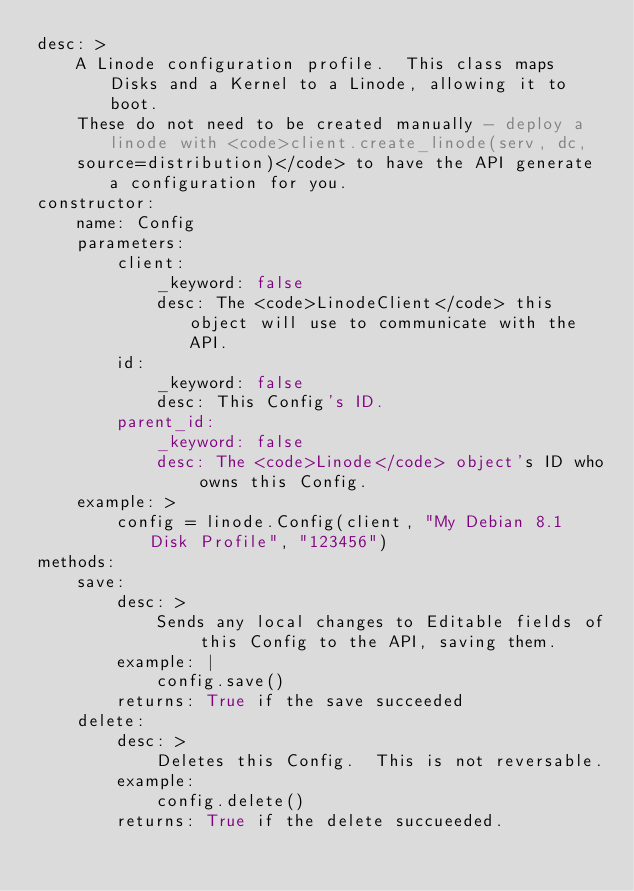<code> <loc_0><loc_0><loc_500><loc_500><_YAML_>desc: >
    A Linode configuration profile.  This class maps Disks and a Kernel to a Linode, allowing it to boot.
    These do not need to be created manually - deploy a linode with <code>client.create_linode(serv, dc, 
    source=distribution)</code> to have the API generate a configuration for you.
constructor:
    name: Config
    parameters:
        client:
            _keyword: false
            desc: The <code>LinodeClient</code> this object will use to communicate with the API.
        id:
            _keyword: false
            desc: This Config's ID.
        parent_id:
            _keyword: false
            desc: The <code>Linode</code> object's ID who owns this Config.
    example: >
        config = linode.Config(client, "My Debian 8.1 Disk Profile", "123456")
methods:
    save:
        desc: >
            Sends any local changes to Editable fields of this Config to the API, saving them.
        example: |
            config.save()
        returns: True if the save succeeded
    delete:
        desc: >
            Deletes this Config.  This is not reversable.
        example:
            config.delete()
        returns: True if the delete succueeded.
</code> 